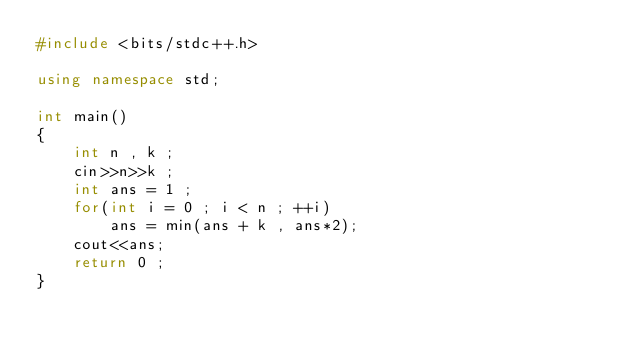Convert code to text. <code><loc_0><loc_0><loc_500><loc_500><_C++_>#include <bits/stdc++.h>

using namespace std;

int main()
{
    int n , k ;
    cin>>n>>k ;
    int ans = 1 ;
    for(int i = 0 ; i < n ; ++i)
        ans = min(ans + k , ans*2);
    cout<<ans;
    return 0 ;
}
</code> 